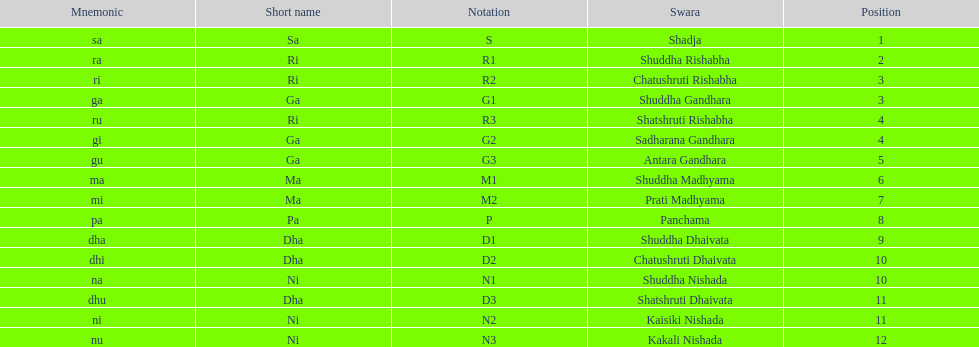Which swara follows immediately after antara gandhara? Shuddha Madhyama. 